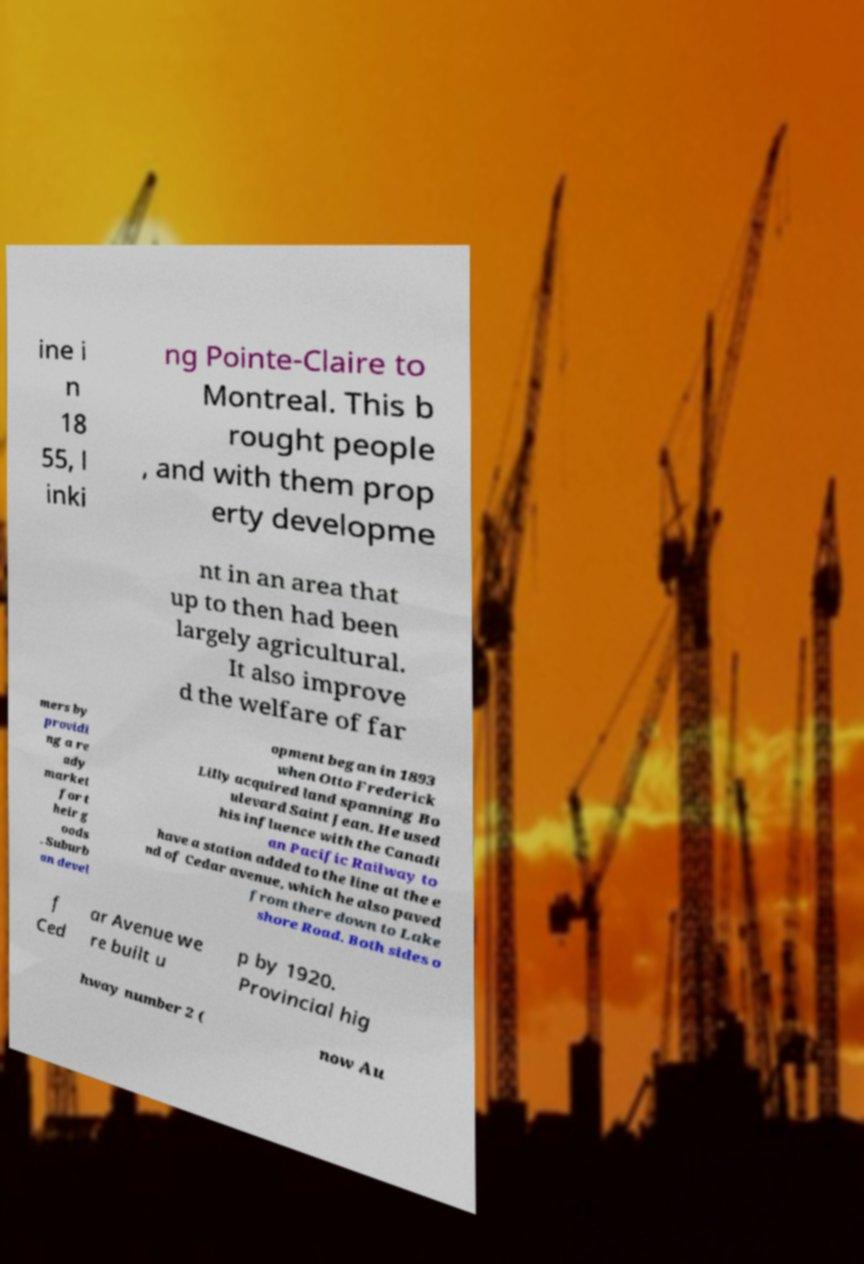Please identify and transcribe the text found in this image. ine i n 18 55, l inki ng Pointe-Claire to Montreal. This b rought people , and with them prop erty developme nt in an area that up to then had been largely agricultural. It also improve d the welfare of far mers by providi ng a re ady market for t heir g oods . Suburb an devel opment began in 1893 when Otto Frederick Lilly acquired land spanning Bo ulevard Saint Jean. He used his influence with the Canadi an Pacific Railway to have a station added to the line at the e nd of Cedar avenue, which he also paved from there down to Lake shore Road. Both sides o f Ced ar Avenue we re built u p by 1920. Provincial hig hway number 2 ( now Au 